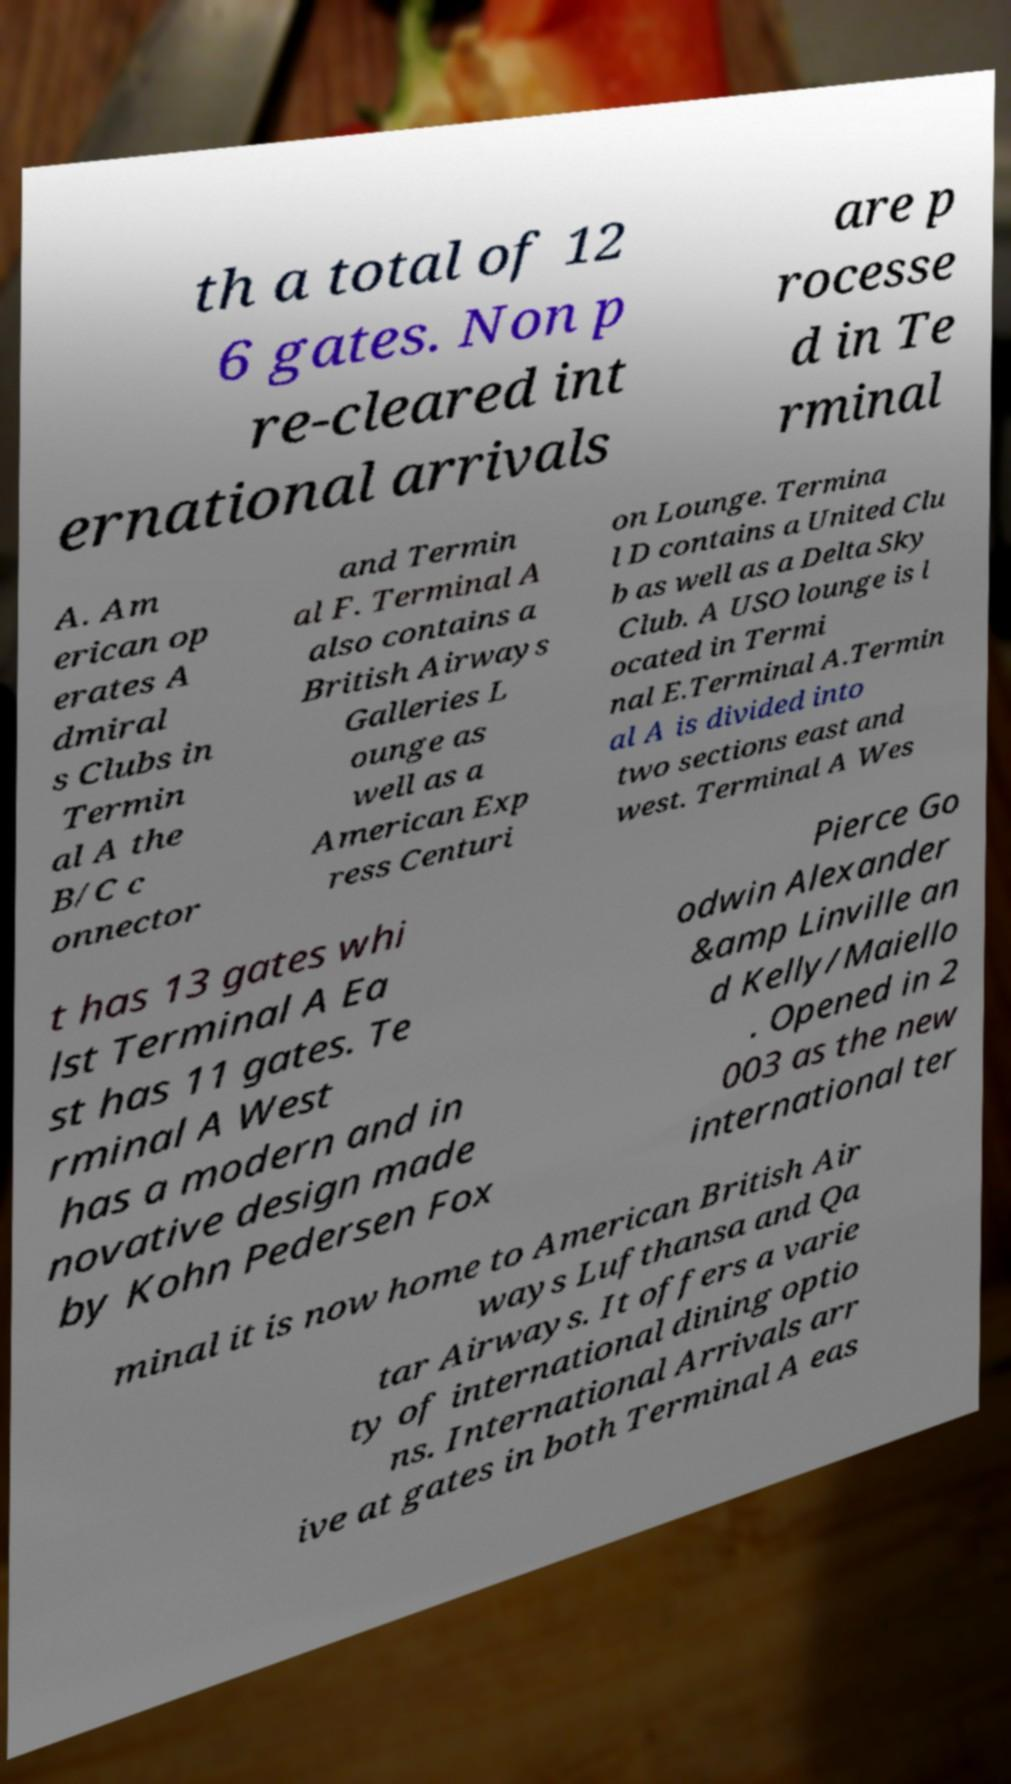For documentation purposes, I need the text within this image transcribed. Could you provide that? th a total of 12 6 gates. Non p re-cleared int ernational arrivals are p rocesse d in Te rminal A. Am erican op erates A dmiral s Clubs in Termin al A the B/C c onnector and Termin al F. Terminal A also contains a British Airways Galleries L ounge as well as a American Exp ress Centuri on Lounge. Termina l D contains a United Clu b as well as a Delta Sky Club. A USO lounge is l ocated in Termi nal E.Terminal A.Termin al A is divided into two sections east and west. Terminal A Wes t has 13 gates whi lst Terminal A Ea st has 11 gates. Te rminal A West has a modern and in novative design made by Kohn Pedersen Fox Pierce Go odwin Alexander &amp Linville an d Kelly/Maiello . Opened in 2 003 as the new international ter minal it is now home to American British Air ways Lufthansa and Qa tar Airways. It offers a varie ty of international dining optio ns. International Arrivals arr ive at gates in both Terminal A eas 